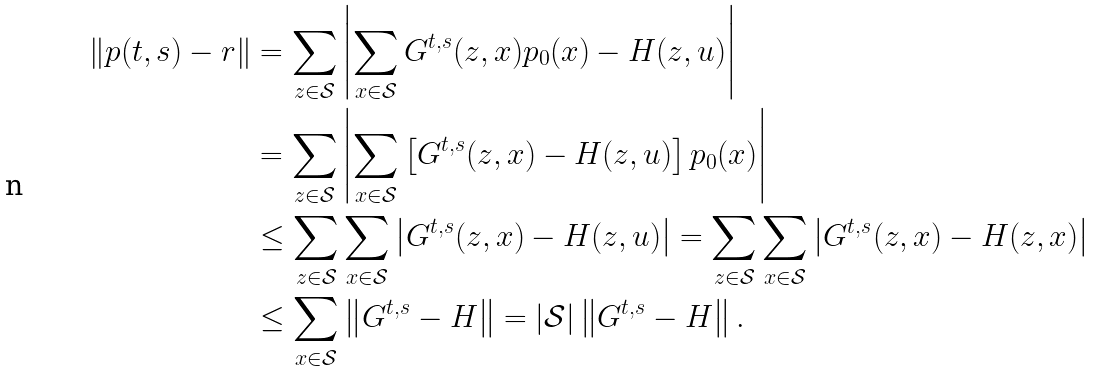<formula> <loc_0><loc_0><loc_500><loc_500>\left \| p ( t , s ) - r \right \| & = \sum _ { z \in \mathcal { S } } \left | \sum _ { x \in \mathcal { S } } G ^ { t , s } ( z , x ) p _ { 0 } ( x ) - H ( z , u ) \right | \\ & = \sum _ { z \in \mathcal { S } } \left | \sum _ { x \in \mathcal { S } } \left [ G ^ { t , s } ( z , x ) - H ( z , u ) \right ] p _ { 0 } ( x ) \right | \\ & \leq \sum _ { z \in \mathcal { S } } \sum _ { x \in \mathcal { S } } \left | G ^ { t , s } ( z , x ) - H ( z , u ) \right | = \sum _ { z \in \mathcal { S } } \sum _ { x \in \mathcal { S } } \left | G ^ { t , s } ( z , x ) - H ( z , x ) \right | \\ & \leq \sum _ { x \in \mathcal { S } } \left \| G ^ { t , s } - H \right \| = \left | \mathcal { S } \right | \left \| G ^ { t , s } - H \right \| .</formula> 